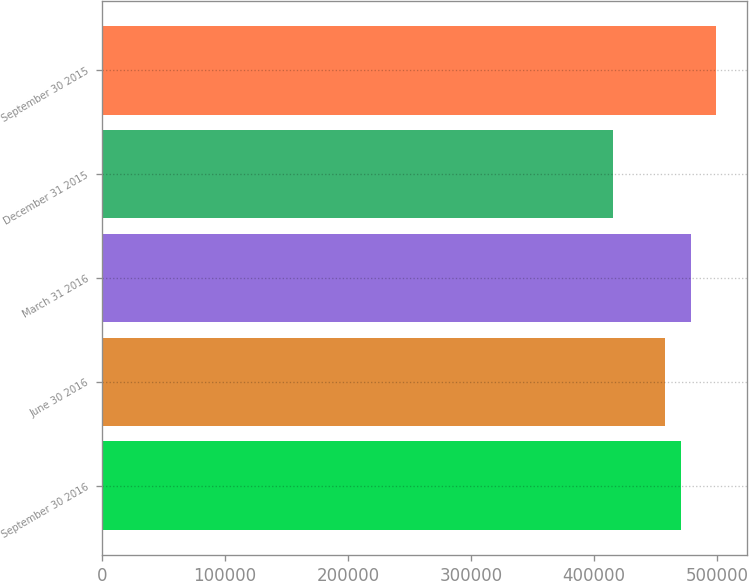<chart> <loc_0><loc_0><loc_500><loc_500><bar_chart><fcel>September 30 2016<fcel>June 30 2016<fcel>March 31 2016<fcel>December 31 2015<fcel>September 30 2015<nl><fcel>470222<fcel>457777<fcel>478574<fcel>415346<fcel>498871<nl></chart> 